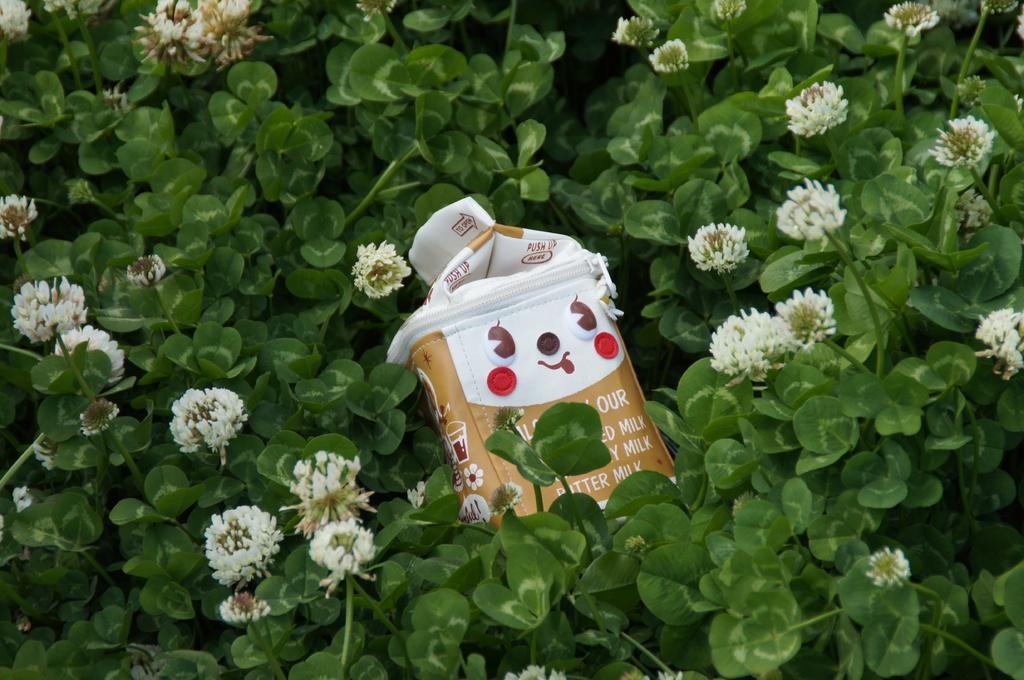How would you summarize this image in a sentence or two? In this image we can see a bag in between the plants with flowers. 